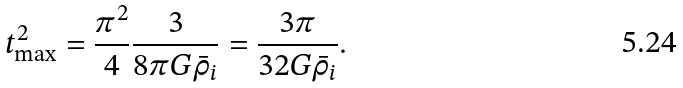<formula> <loc_0><loc_0><loc_500><loc_500>t _ { \max } ^ { 2 } = \frac { \pi ^ { 2 } } { 4 } \frac { 3 } { 8 \pi G \bar { \rho } _ { i } } = \frac { 3 \pi } { 3 2 G \bar { \rho } _ { i } } .</formula> 